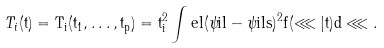<formula> <loc_0><loc_0><loc_500><loc_500>T _ { i } ( \tt t ) = T _ { i } ( t _ { 1 } , \dots , t _ { p } ) = t _ { i } ^ { 2 } \int e l ( \psi i l - \psi i l s ) ^ { 2 } f ( \lll | \tt t ) d \lll .</formula> 